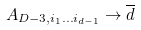Convert formula to latex. <formula><loc_0><loc_0><loc_500><loc_500>A _ { D - 3 , i _ { 1 } \dots i _ { d - 1 } } \rightarrow { \overline { d } }</formula> 